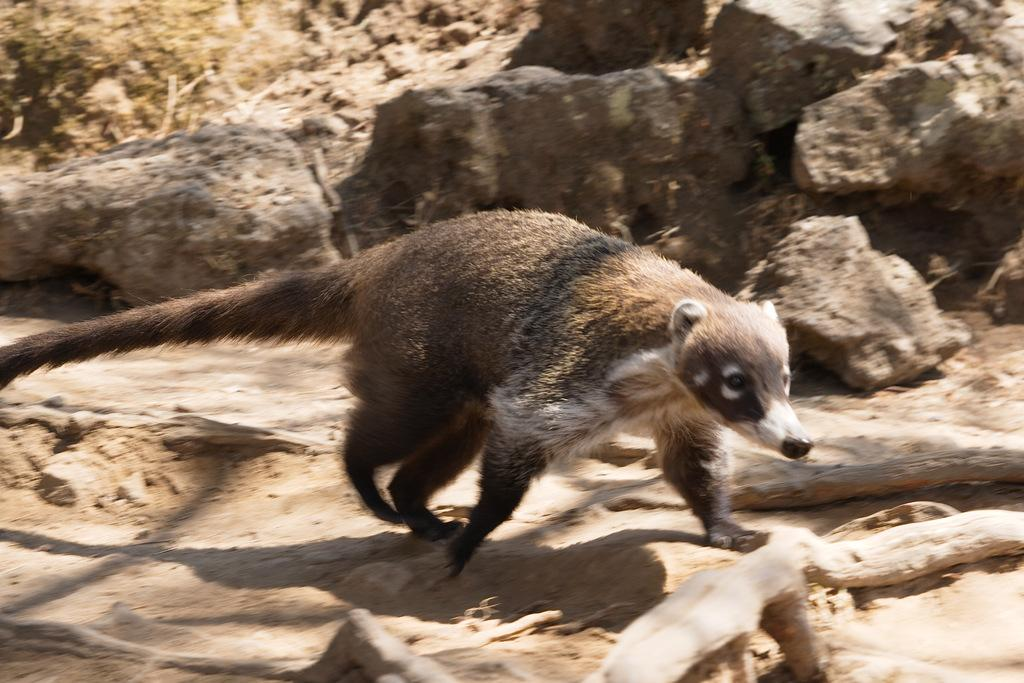What type of animal can be seen in the image? There is a brown and white colored animal in the image. Can you describe any other visual elements in the image? The image has a shadow. How would you describe the quality of the background in the image? The background of the image is slightly blurry. How many women are present in the image? There are no women present in the image; it features a brown and white colored animal. What year is depicted in the image? The image does not depict a specific year; it is a photograph of an animal with a shadow and a slightly blurry background. 